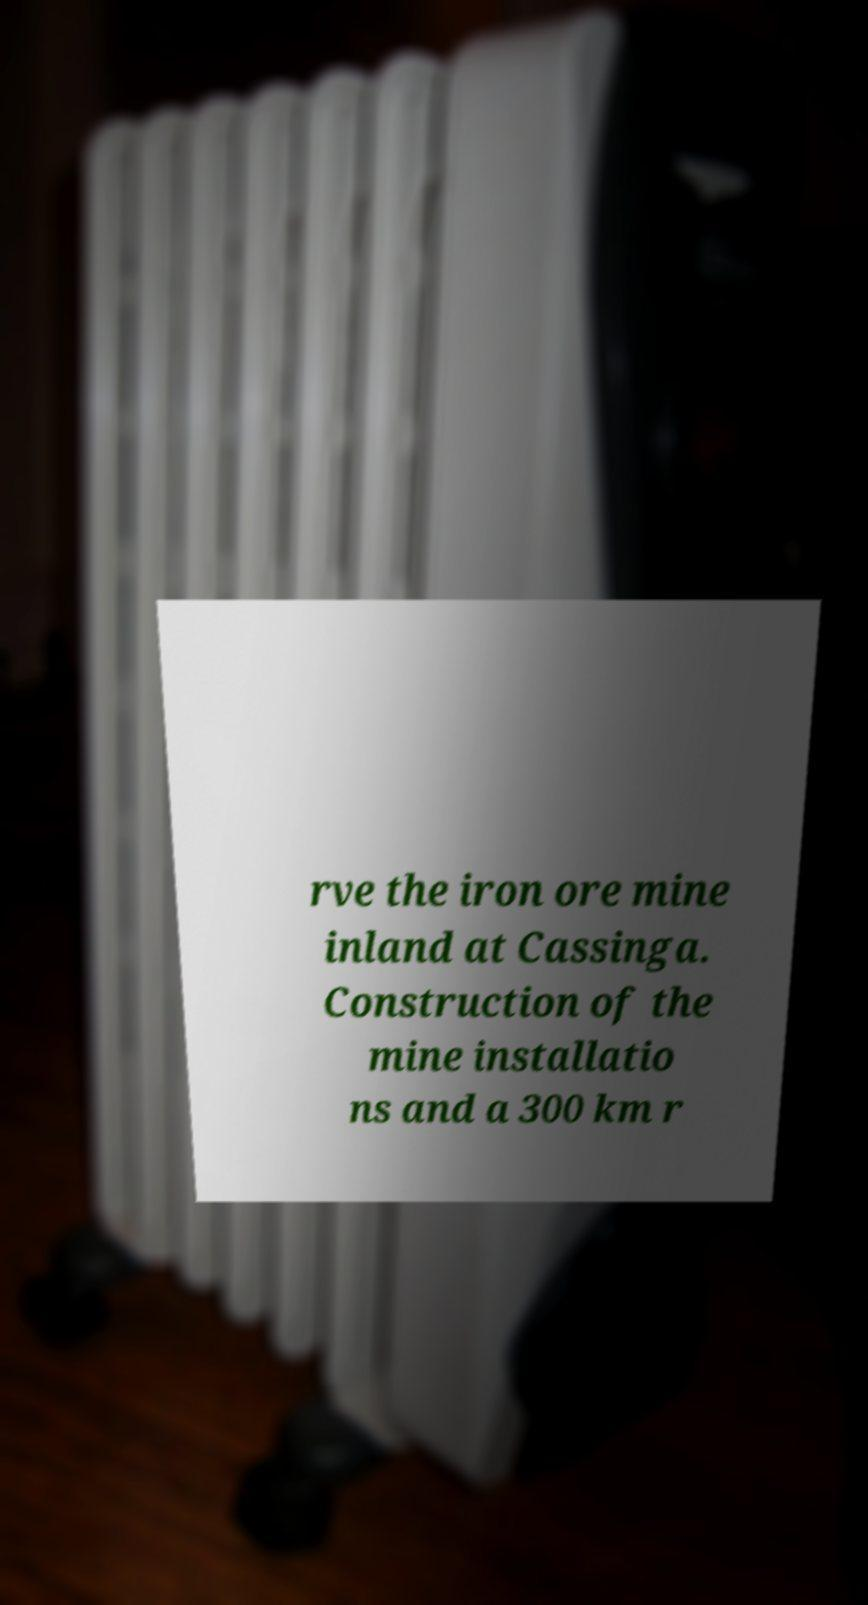What messages or text are displayed in this image? I need them in a readable, typed format. rve the iron ore mine inland at Cassinga. Construction of the mine installatio ns and a 300 km r 